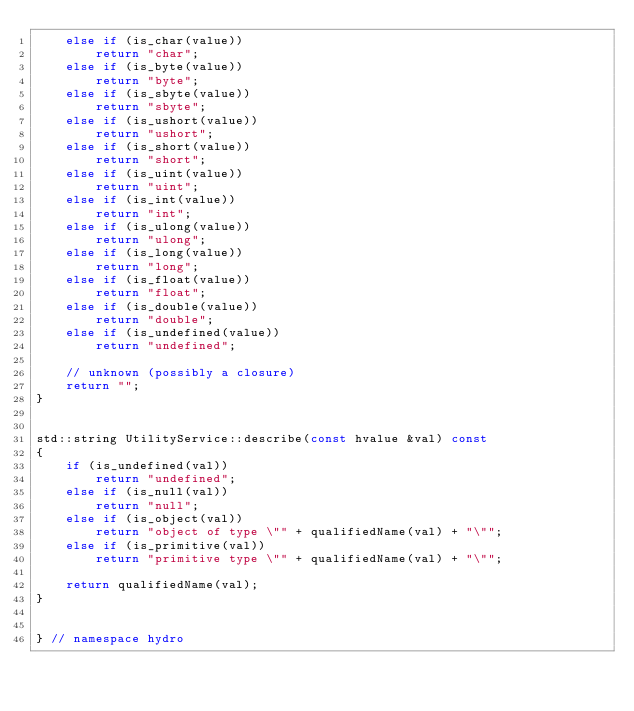<code> <loc_0><loc_0><loc_500><loc_500><_C++_>    else if (is_char(value))
        return "char";
    else if (is_byte(value))
        return "byte";
    else if (is_sbyte(value))
        return "sbyte";
    else if (is_ushort(value))
        return "ushort";
    else if (is_short(value))
        return "short";
    else if (is_uint(value))
        return "uint";
    else if (is_int(value))
        return "int";
    else if (is_ulong(value))
        return "ulong";
    else if (is_long(value))
        return "long";
    else if (is_float(value))
        return "float";
    else if (is_double(value))
        return "double";
    else if (is_undefined(value))
        return "undefined";

    // unknown (possibly a closure)
    return "";
}


std::string UtilityService::describe(const hvalue &val) const
{
    if (is_undefined(val))
        return "undefined";
    else if (is_null(val))
        return "null";
    else if (is_object(val))
        return "object of type \"" + qualifiedName(val) + "\"";
    else if (is_primitive(val))
        return "primitive type \"" + qualifiedName(val) + "\"";

    return qualifiedName(val);
}


} // namespace hydro
</code> 